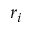Convert formula to latex. <formula><loc_0><loc_0><loc_500><loc_500>r _ { i }</formula> 